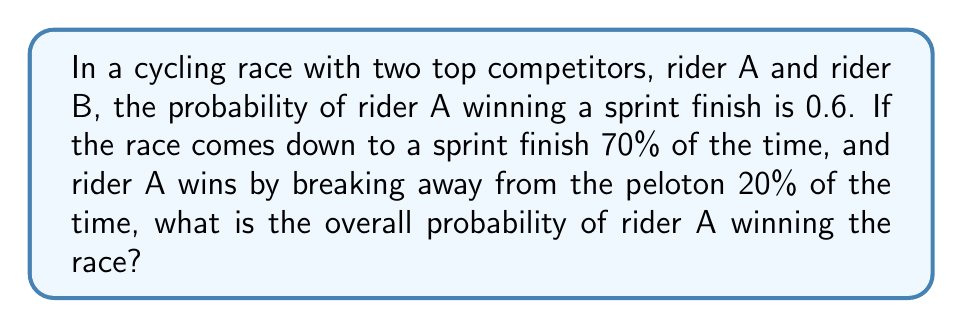Could you help me with this problem? Let's approach this step-by-step using probability theory:

1) Define events:
   S: The race ends in a sprint finish
   B: Rider A wins by breaking away
   W: Rider A wins the race

2) Given probabilities:
   P(S) = 0.7 (70% chance of sprint finish)
   P(B) = 0.2 (20% chance of winning by break away)
   P(A wins sprint | S) = 0.6 (60% chance of winning if it's a sprint)

3) Calculate P(W):
   P(W) = P(W|S) * P(S) + P(B)

   Here, P(W|S) is the probability of A winning given that it's a sprint finish, which is 0.6.

4) Substitute the values:
   P(W) = 0.6 * 0.7 + 0.2

5) Calculate:
   P(W) = 0.42 + 0.2 = 0.62

Therefore, the overall probability of rider A winning the race is 0.62 or 62%.
Answer: 0.62 